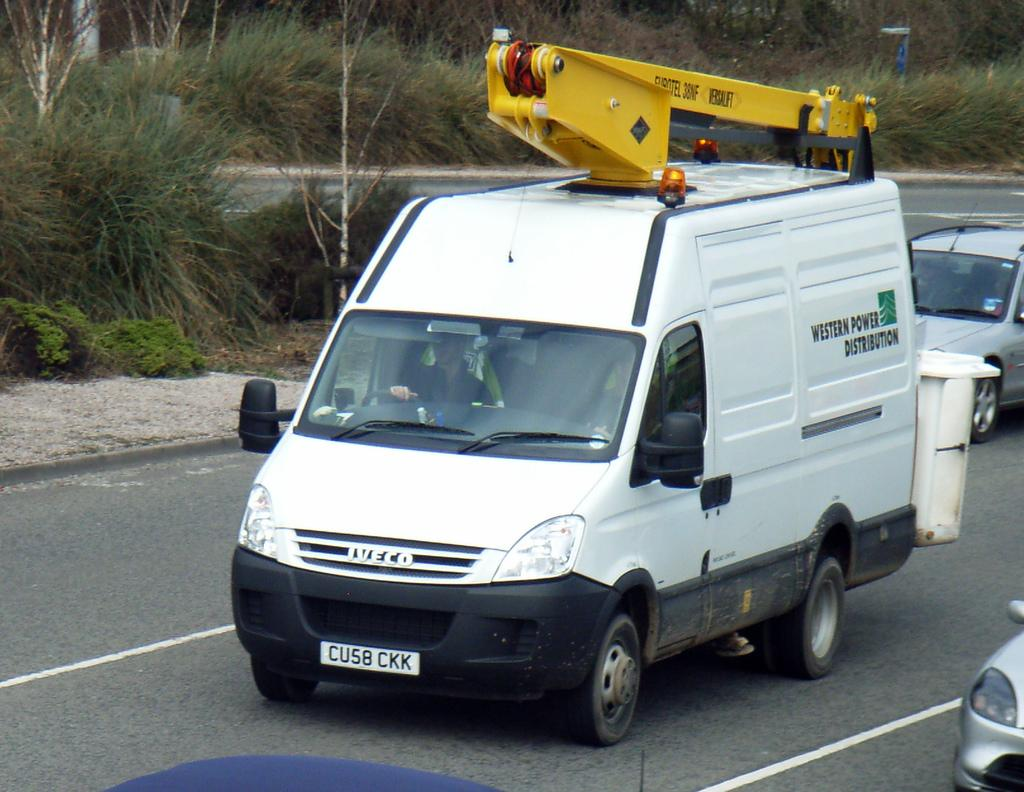Provide a one-sentence caption for the provided image. a WESTERN POWER DISTRIBUTION company van with a CU58 CKK license plate. 